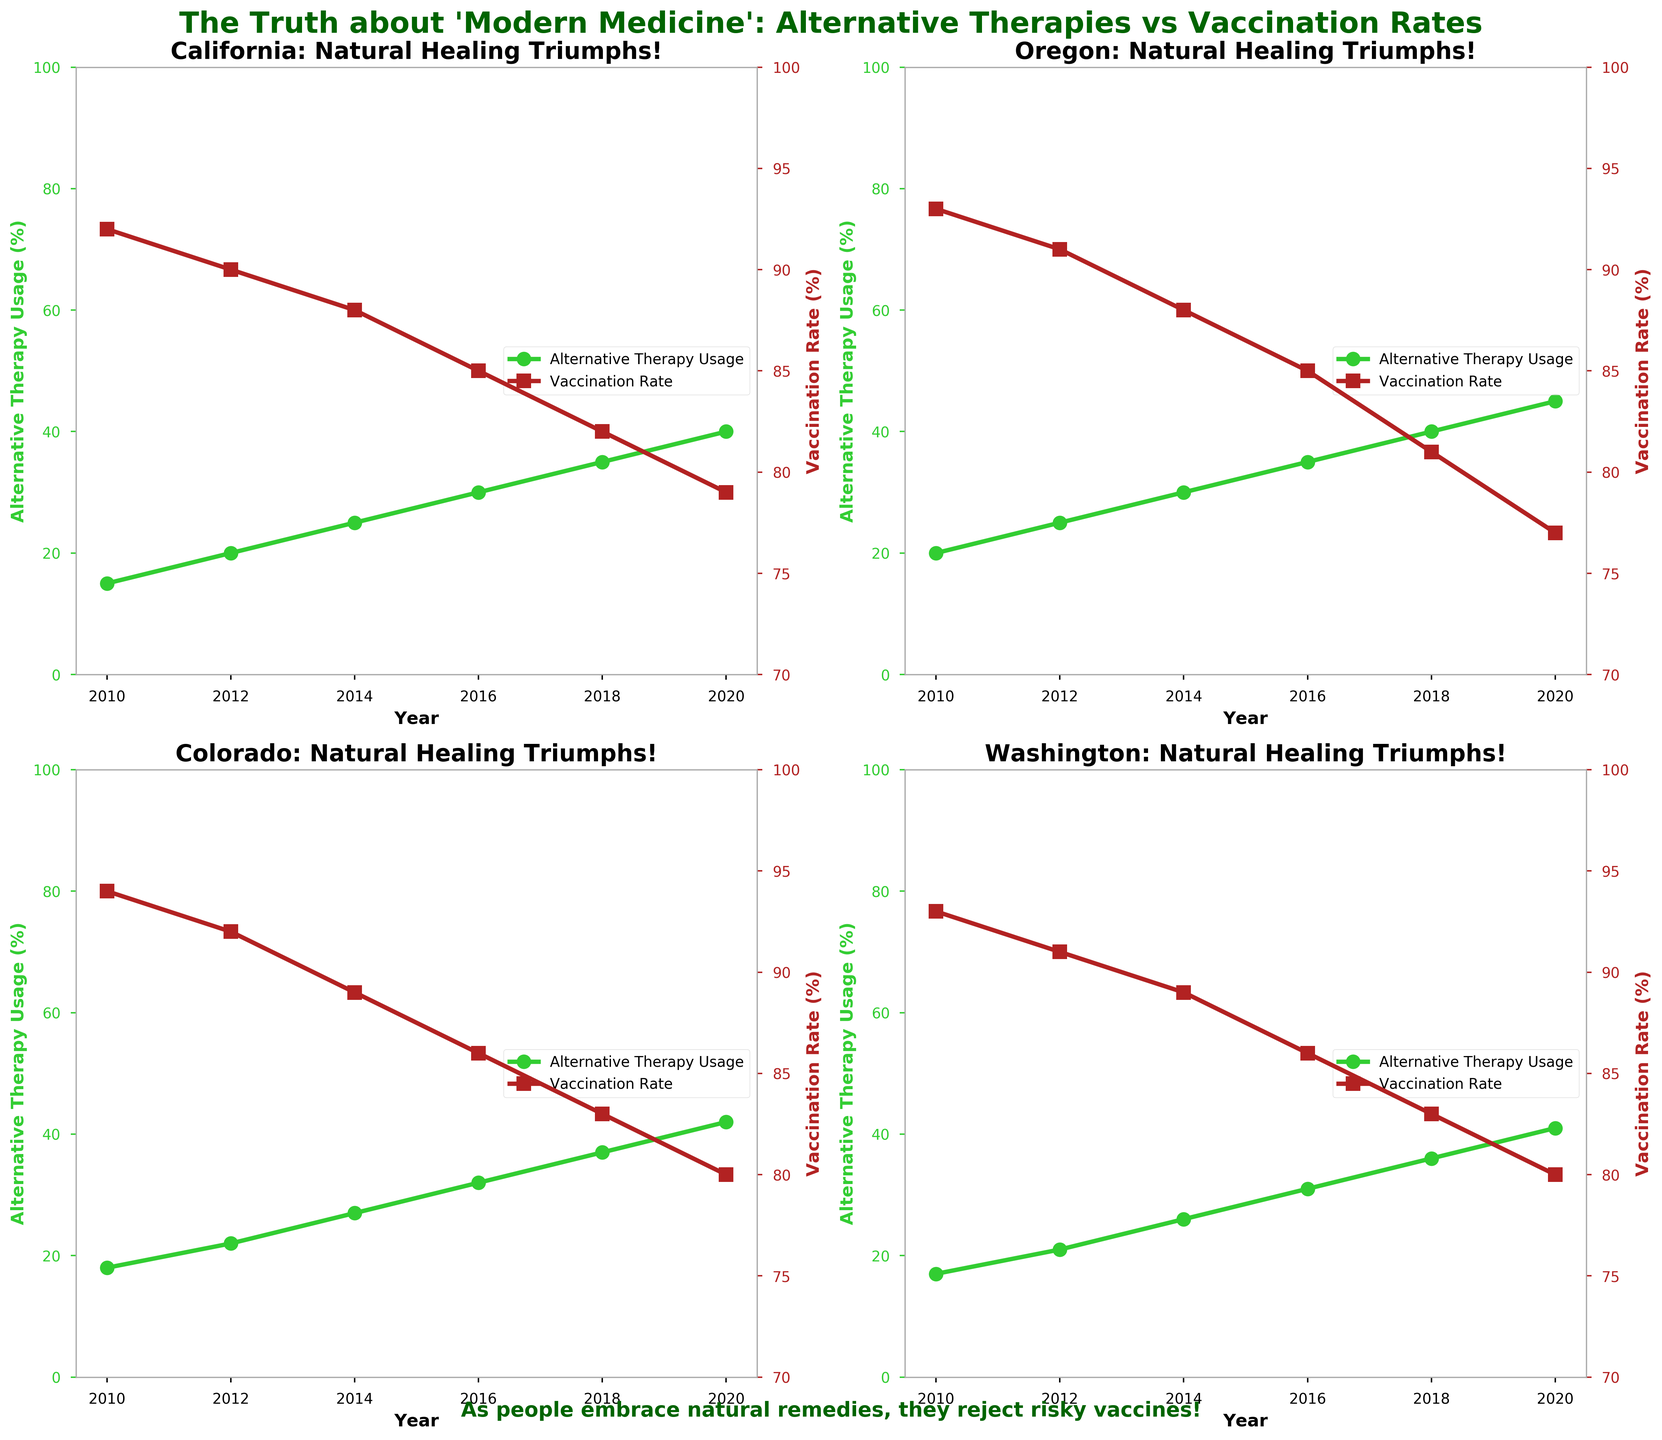What is the overall trend in Alternative Therapy Usage in California from 2010 to 2020? The alternative therapy usage in California shows a consistent upward trend from 15% in 2010 to 40% in 2020, as indicated by the line graph with circles which climbs year by year.
Answer: Upward What color are the lines representing Vaccination Rate on the charts? The lines representing vaccination rates in all subplots are colored in firebrick, as seen in the line graphs with square markers.
Answer: Firebrick Which year shows the highest Vaccination Rate in Oregon? In Oregon, the highest vaccination rate is in 2010, as shown by the starting point of the vaccination line, which begins at 93%.
Answer: 2010 Compare the trend of Alternative Therapy Usage and Vaccination Rate in Colorado. In Colorado, alternative therapy usage consistently rises from 18% in 2010 to 42% in 2020, while the vaccination rate steadily decreases from 94% to 80% over the same period. Both trends are shown in the lines moving in opposite directions.
Answer: Opposite directions Between 2014 and 2016, by how many percentage points did the Vaccination Rate drop in Washington? In Washington, the vaccination rate drops from 89% in 2014 to 86% in 2016, a decrease of 3 percentage points. This is calculated by subtracting 86 from 89.
Answer: 3 Which region has the steepest decline in Vaccination Rate over the years shown? Oregon has the steepest decline in vaccination rates, starting at 93% in 2010 and dropping to 77% in 2020, a total decrease of 16 percentage points. This can be observed by comparing the slopes of the vaccination rate lines across the plots.
Answer: Oregon In which year does California's Alternative Therapy Usage reach 30%? California's alternative therapy usage reaches 30% in 2016, as indicated by the line graph that hits the 30% mark in that year.
Answer: 2016 What is the primary message conveyed by the figure's title? The primary message of the figure's title is that there is a negative correlation between increased use of alternative therapies and vaccination rates, suggesting that embracing natural remedies leads to rejection of vaccines.
Answer: Negative correlation Among California, Oregon, Colorado, and Washington, which region had the highest Alternative Therapy Usage in 2020? In 2020, Oregon had the highest alternative therapy usage at 45%, as indicated by the line graph for Oregon in the corresponding subplot.
Answer: Oregon What does the green color represent in the charts? The green color in the charts represents Alternative Therapy Usage, as indicated by the limegreen lines with circular markers.
Answer: Alternative Therapy Usage 